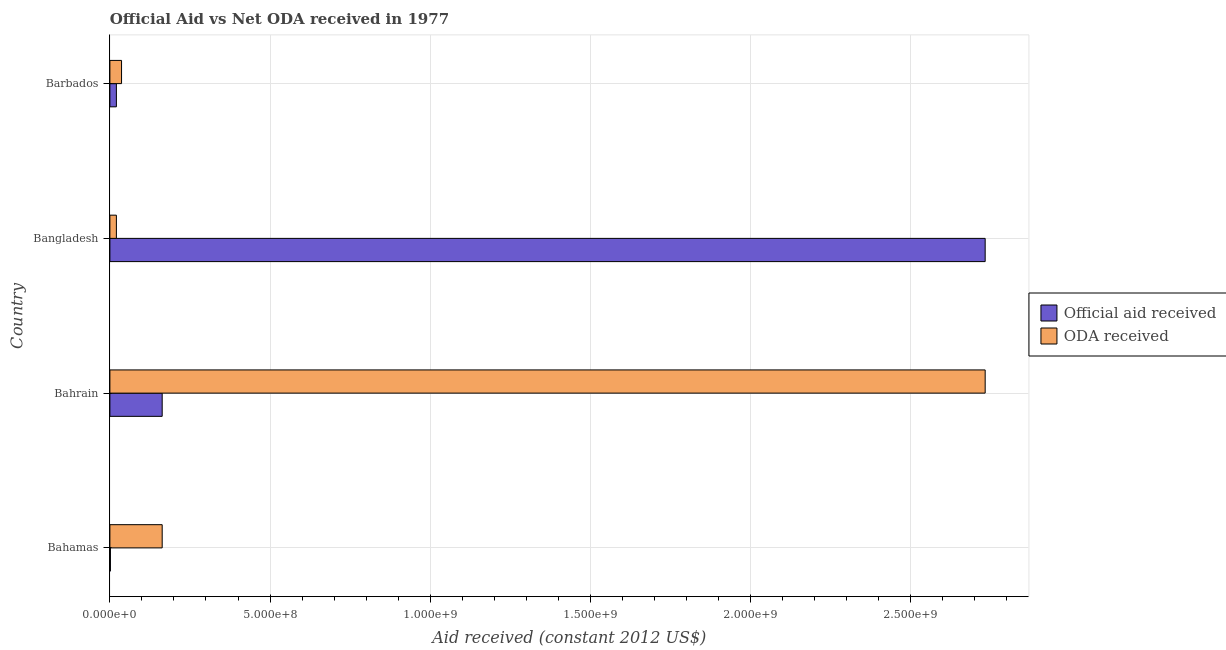How many different coloured bars are there?
Your answer should be compact. 2. Are the number of bars per tick equal to the number of legend labels?
Your answer should be very brief. Yes. How many bars are there on the 3rd tick from the top?
Provide a short and direct response. 2. How many bars are there on the 4th tick from the bottom?
Keep it short and to the point. 2. What is the label of the 2nd group of bars from the top?
Provide a succinct answer. Bangladesh. In how many cases, is the number of bars for a given country not equal to the number of legend labels?
Offer a very short reply. 0. What is the oda received in Bangladesh?
Ensure brevity in your answer.  2.03e+07. Across all countries, what is the maximum oda received?
Ensure brevity in your answer.  2.73e+09. Across all countries, what is the minimum oda received?
Make the answer very short. 2.03e+07. In which country was the official aid received maximum?
Provide a succinct answer. Bangladesh. In which country was the official aid received minimum?
Offer a terse response. Bahamas. What is the total oda received in the graph?
Offer a very short reply. 2.95e+09. What is the difference between the official aid received in Bahamas and that in Bangladesh?
Offer a terse response. -2.73e+09. What is the difference between the official aid received in Bangladesh and the oda received in Bahamas?
Provide a short and direct response. 2.57e+09. What is the average official aid received per country?
Keep it short and to the point. 7.29e+08. What is the difference between the oda received and official aid received in Bangladesh?
Ensure brevity in your answer.  -2.71e+09. In how many countries, is the official aid received greater than 700000000 US$?
Give a very brief answer. 1. Is the difference between the oda received in Bahamas and Bahrain greater than the difference between the official aid received in Bahamas and Bahrain?
Your answer should be very brief. No. What is the difference between the highest and the second highest official aid received?
Offer a terse response. 2.57e+09. What is the difference between the highest and the lowest oda received?
Provide a short and direct response. 2.71e+09. Is the sum of the oda received in Bangladesh and Barbados greater than the maximum official aid received across all countries?
Offer a terse response. No. What does the 2nd bar from the top in Barbados represents?
Give a very brief answer. Official aid received. What does the 1st bar from the bottom in Barbados represents?
Offer a terse response. Official aid received. Are all the bars in the graph horizontal?
Ensure brevity in your answer.  Yes. How many countries are there in the graph?
Your answer should be very brief. 4. What is the title of the graph?
Provide a short and direct response. Official Aid vs Net ODA received in 1977 . Does "Money lenders" appear as one of the legend labels in the graph?
Offer a very short reply. No. What is the label or title of the X-axis?
Give a very brief answer. Aid received (constant 2012 US$). What is the label or title of the Y-axis?
Your answer should be compact. Country. What is the Aid received (constant 2012 US$) of Official aid received in Bahamas?
Ensure brevity in your answer.  1.62e+06. What is the Aid received (constant 2012 US$) in ODA received in Bahamas?
Ensure brevity in your answer.  1.63e+08. What is the Aid received (constant 2012 US$) of Official aid received in Bahrain?
Your response must be concise. 1.63e+08. What is the Aid received (constant 2012 US$) in ODA received in Bahrain?
Keep it short and to the point. 2.73e+09. What is the Aid received (constant 2012 US$) of Official aid received in Bangladesh?
Ensure brevity in your answer.  2.73e+09. What is the Aid received (constant 2012 US$) of ODA received in Bangladesh?
Your answer should be very brief. 2.03e+07. What is the Aid received (constant 2012 US$) in Official aid received in Barbados?
Keep it short and to the point. 2.03e+07. What is the Aid received (constant 2012 US$) in ODA received in Barbados?
Offer a terse response. 3.64e+07. Across all countries, what is the maximum Aid received (constant 2012 US$) in Official aid received?
Keep it short and to the point. 2.73e+09. Across all countries, what is the maximum Aid received (constant 2012 US$) of ODA received?
Offer a terse response. 2.73e+09. Across all countries, what is the minimum Aid received (constant 2012 US$) in Official aid received?
Offer a terse response. 1.62e+06. Across all countries, what is the minimum Aid received (constant 2012 US$) of ODA received?
Provide a short and direct response. 2.03e+07. What is the total Aid received (constant 2012 US$) in Official aid received in the graph?
Your response must be concise. 2.92e+09. What is the total Aid received (constant 2012 US$) of ODA received in the graph?
Offer a very short reply. 2.95e+09. What is the difference between the Aid received (constant 2012 US$) of Official aid received in Bahamas and that in Bahrain?
Keep it short and to the point. -1.62e+08. What is the difference between the Aid received (constant 2012 US$) of ODA received in Bahamas and that in Bahrain?
Give a very brief answer. -2.57e+09. What is the difference between the Aid received (constant 2012 US$) of Official aid received in Bahamas and that in Bangladesh?
Your answer should be compact. -2.73e+09. What is the difference between the Aid received (constant 2012 US$) in ODA received in Bahamas and that in Bangladesh?
Ensure brevity in your answer.  1.43e+08. What is the difference between the Aid received (constant 2012 US$) of Official aid received in Bahamas and that in Barbados?
Make the answer very short. -1.86e+07. What is the difference between the Aid received (constant 2012 US$) of ODA received in Bahamas and that in Barbados?
Your answer should be very brief. 1.27e+08. What is the difference between the Aid received (constant 2012 US$) of Official aid received in Bahrain and that in Bangladesh?
Offer a very short reply. -2.57e+09. What is the difference between the Aid received (constant 2012 US$) in ODA received in Bahrain and that in Bangladesh?
Give a very brief answer. 2.71e+09. What is the difference between the Aid received (constant 2012 US$) of Official aid received in Bahrain and that in Barbados?
Provide a succinct answer. 1.43e+08. What is the difference between the Aid received (constant 2012 US$) of ODA received in Bahrain and that in Barbados?
Give a very brief answer. 2.70e+09. What is the difference between the Aid received (constant 2012 US$) in Official aid received in Bangladesh and that in Barbados?
Your answer should be compact. 2.71e+09. What is the difference between the Aid received (constant 2012 US$) of ODA received in Bangladesh and that in Barbados?
Give a very brief answer. -1.61e+07. What is the difference between the Aid received (constant 2012 US$) of Official aid received in Bahamas and the Aid received (constant 2012 US$) of ODA received in Bahrain?
Your response must be concise. -2.73e+09. What is the difference between the Aid received (constant 2012 US$) in Official aid received in Bahamas and the Aid received (constant 2012 US$) in ODA received in Bangladesh?
Give a very brief answer. -1.86e+07. What is the difference between the Aid received (constant 2012 US$) in Official aid received in Bahamas and the Aid received (constant 2012 US$) in ODA received in Barbados?
Offer a terse response. -3.48e+07. What is the difference between the Aid received (constant 2012 US$) in Official aid received in Bahrain and the Aid received (constant 2012 US$) in ODA received in Bangladesh?
Provide a short and direct response. 1.43e+08. What is the difference between the Aid received (constant 2012 US$) of Official aid received in Bahrain and the Aid received (constant 2012 US$) of ODA received in Barbados?
Offer a very short reply. 1.27e+08. What is the difference between the Aid received (constant 2012 US$) of Official aid received in Bangladesh and the Aid received (constant 2012 US$) of ODA received in Barbados?
Provide a short and direct response. 2.70e+09. What is the average Aid received (constant 2012 US$) in Official aid received per country?
Make the answer very short. 7.29e+08. What is the average Aid received (constant 2012 US$) of ODA received per country?
Keep it short and to the point. 7.38e+08. What is the difference between the Aid received (constant 2012 US$) in Official aid received and Aid received (constant 2012 US$) in ODA received in Bahamas?
Your answer should be compact. -1.62e+08. What is the difference between the Aid received (constant 2012 US$) of Official aid received and Aid received (constant 2012 US$) of ODA received in Bahrain?
Provide a short and direct response. -2.57e+09. What is the difference between the Aid received (constant 2012 US$) in Official aid received and Aid received (constant 2012 US$) in ODA received in Bangladesh?
Your answer should be compact. 2.71e+09. What is the difference between the Aid received (constant 2012 US$) of Official aid received and Aid received (constant 2012 US$) of ODA received in Barbados?
Give a very brief answer. -1.61e+07. What is the ratio of the Aid received (constant 2012 US$) in Official aid received in Bahamas to that in Bahrain?
Ensure brevity in your answer.  0.01. What is the ratio of the Aid received (constant 2012 US$) of ODA received in Bahamas to that in Bahrain?
Your response must be concise. 0.06. What is the ratio of the Aid received (constant 2012 US$) in Official aid received in Bahamas to that in Bangladesh?
Offer a terse response. 0. What is the ratio of the Aid received (constant 2012 US$) of ODA received in Bahamas to that in Bangladesh?
Offer a very short reply. 8.06. What is the ratio of the Aid received (constant 2012 US$) of Official aid received in Bahamas to that in Barbados?
Provide a succinct answer. 0.08. What is the ratio of the Aid received (constant 2012 US$) of ODA received in Bahamas to that in Barbados?
Give a very brief answer. 4.49. What is the ratio of the Aid received (constant 2012 US$) of Official aid received in Bahrain to that in Bangladesh?
Give a very brief answer. 0.06. What is the ratio of the Aid received (constant 2012 US$) in ODA received in Bahrain to that in Bangladesh?
Your answer should be very brief. 134.81. What is the ratio of the Aid received (constant 2012 US$) in Official aid received in Bahrain to that in Barbados?
Ensure brevity in your answer.  8.06. What is the ratio of the Aid received (constant 2012 US$) of ODA received in Bahrain to that in Barbados?
Keep it short and to the point. 75.13. What is the ratio of the Aid received (constant 2012 US$) of Official aid received in Bangladesh to that in Barbados?
Your response must be concise. 134.81. What is the ratio of the Aid received (constant 2012 US$) in ODA received in Bangladesh to that in Barbados?
Offer a very short reply. 0.56. What is the difference between the highest and the second highest Aid received (constant 2012 US$) of Official aid received?
Keep it short and to the point. 2.57e+09. What is the difference between the highest and the second highest Aid received (constant 2012 US$) of ODA received?
Offer a very short reply. 2.57e+09. What is the difference between the highest and the lowest Aid received (constant 2012 US$) of Official aid received?
Keep it short and to the point. 2.73e+09. What is the difference between the highest and the lowest Aid received (constant 2012 US$) of ODA received?
Keep it short and to the point. 2.71e+09. 